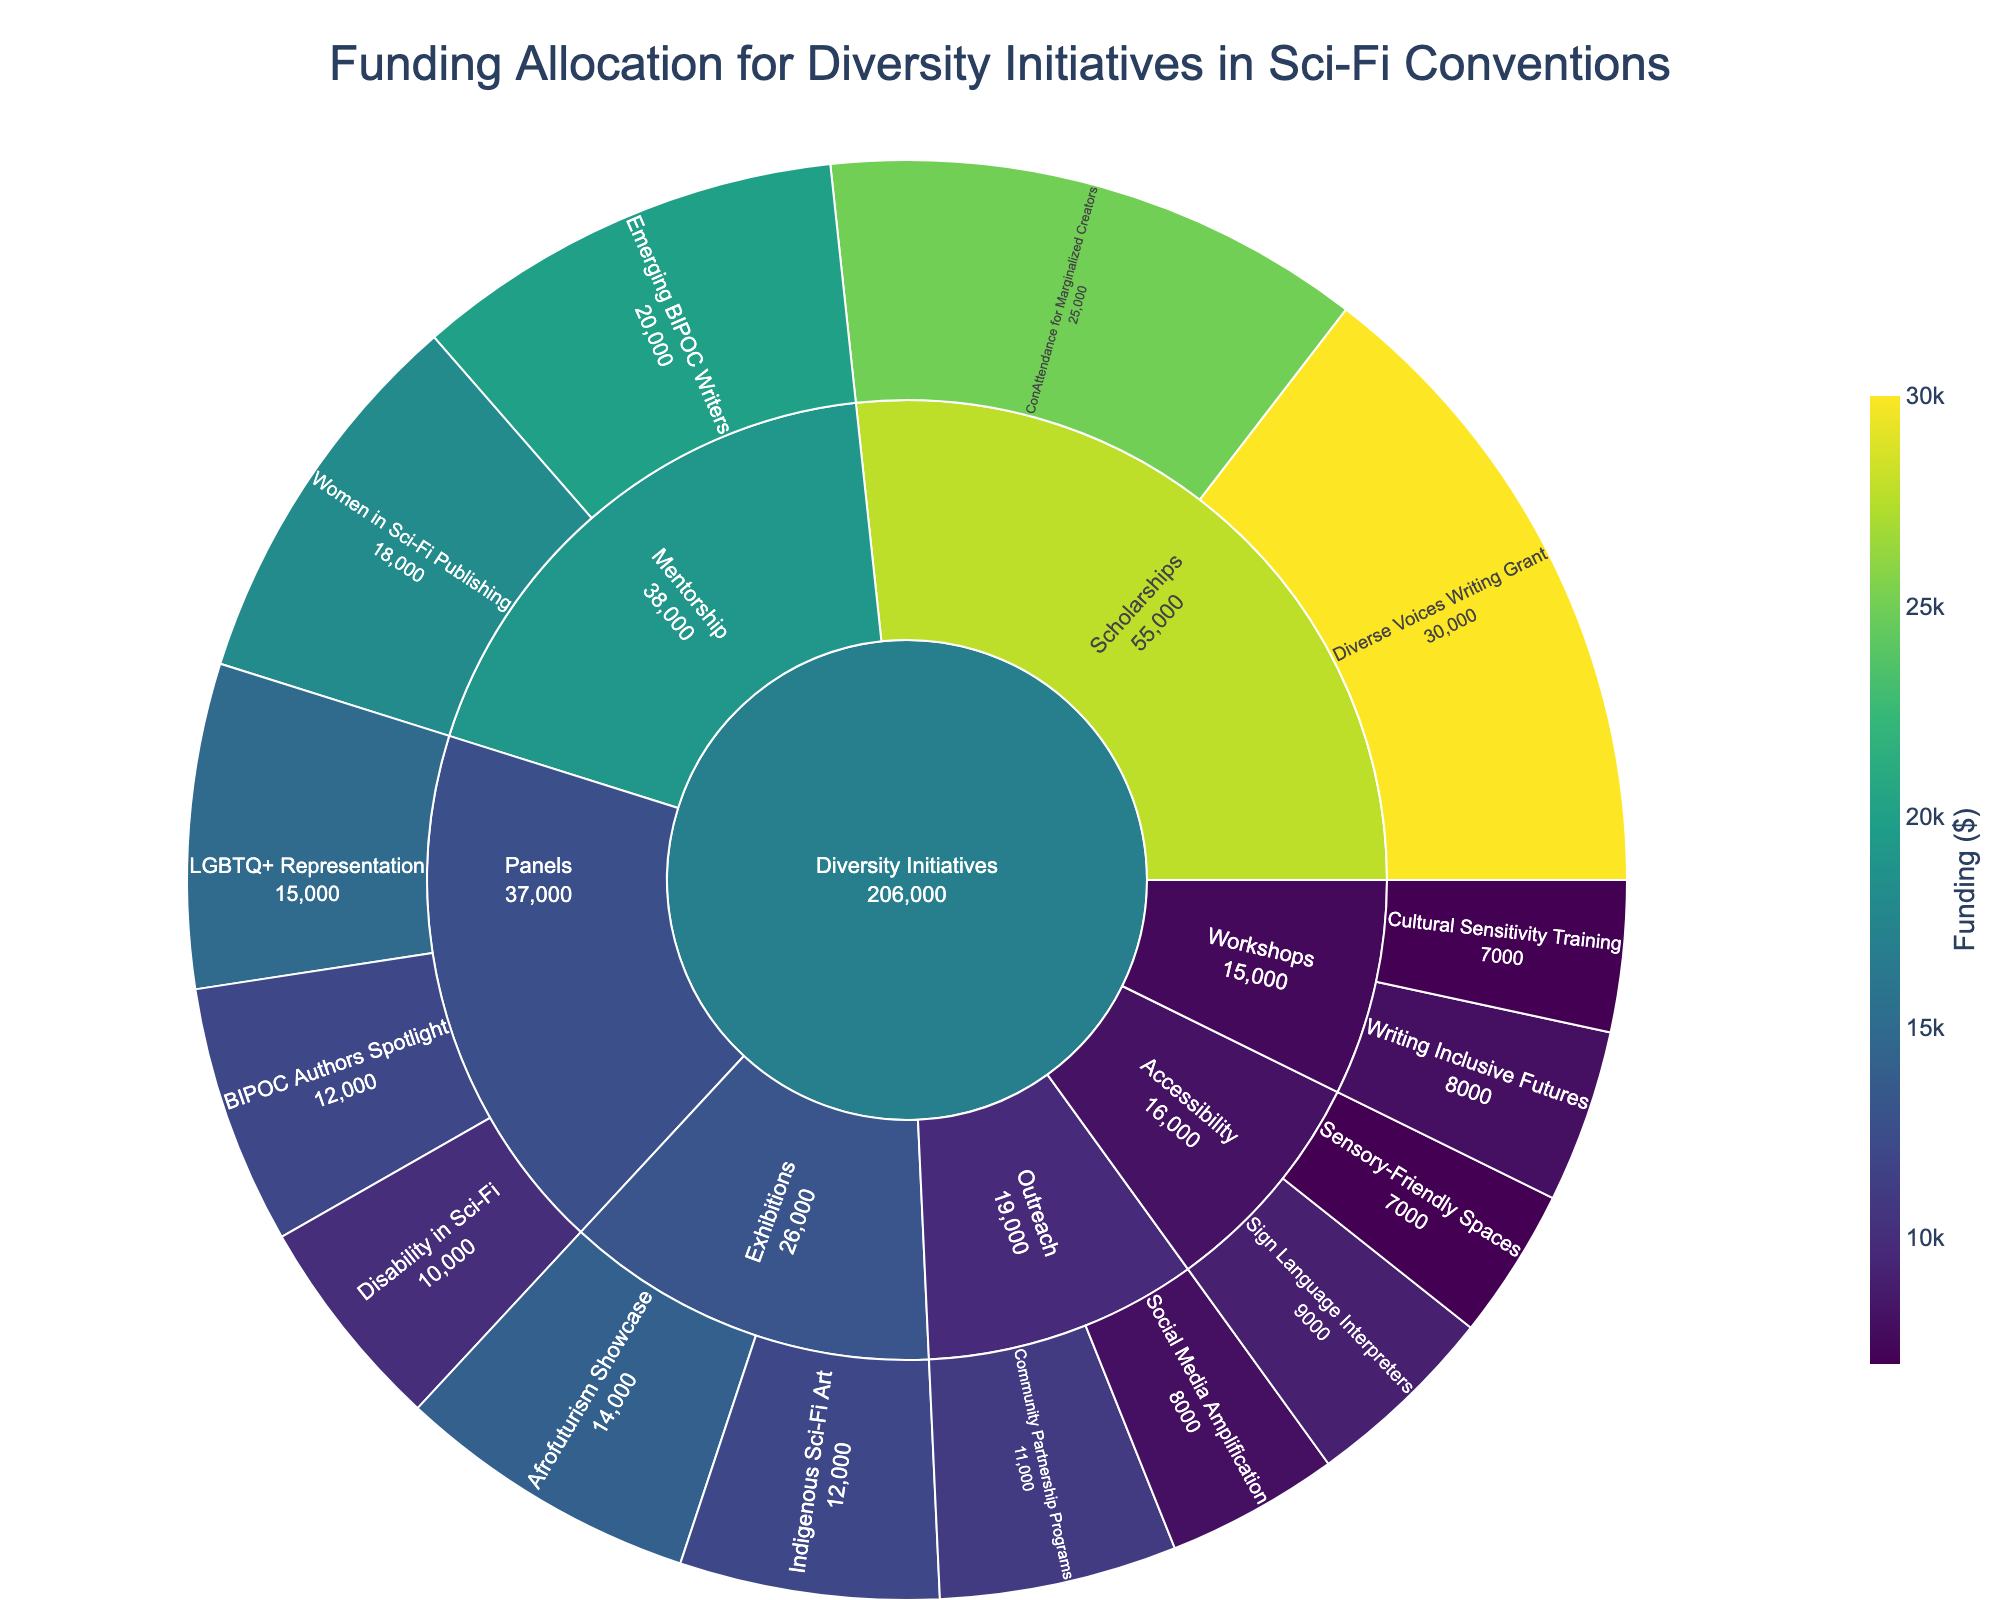What's the largest funding allocation under Diversity Initiatives? Look at the funding values under each program and identify the highest one. The largest funding allocation is for the "Diverse Voices Writing Grant" under Scholarships with $30,000.
Answer: $30,000 How much more funding does Mentorship receive compared to Panels? Add up the funding for all programs under Mentorship and Panels, then subtract the total for Panels from the total for Mentorship. Panels: 15,000 + 12,000 + 10,000 = 37,000, Mentorship: 20,000 + 18,000 = 38,000, Difference: 38,000 - 37,000 = 1,000
Answer: $1,000 Which subcategory has the least amount of funding? Identify the smallest total funding value among the subcategories. The subcategory with the least amount of funding is Accessibility with a combined funding of $16,000.
Answer: Accessibility How is the funding distributed among Workshops? Look at the funding values for each program under Workshops and list them. "Writing Inclusive Futures" receives $8,000, and "Cultural Sensitivity Training" receives $7,000.
Answer: $8,000 for Writing Inclusive Futures, $7,000 for Cultural Sensitivity Training Which program in the Outreach subcategory has higher funding? Compare the funding for "Community Partnership Programs" and "Social Media Amplification". "Community Partnership Programs" has $11,000, and "Social Media Amplification" has $8,000.
Answer: Community Partnership Programs What is the total funding allocated to Exhibitions? Add up the funding values for all programs under Exhibitions. "Afrofuturism Showcase" receives $14,000, and "Indigenous Sci-Fi Art" receives $12,000, so the total is 14,000 + 12,000 = 26,000.
Answer: $26,000 Which has more funding: Scholarships or Accessibility? Compare the total funding for Scholarships and Accessibility. Scholarships: 25,000 + 30,000 = 55,000, Accessibility: 9,000 + 7,000 = 16,000. Scholarships have more funding than Accessibility.
Answer: Scholarships What is the overall funding for all diversity initiatives? Sum up the funding for all programs listed in the dataset. Total funding: 15,000 + 12,000 + 10,000 + 8,000 + 7,000 + 20,000 + 18,000 + 25,000 + 30,000 + 14,000 + 12,000 + 9,000 + 7,000 + 11,000 + 8,000 = 196,000.
Answer: $196,000 